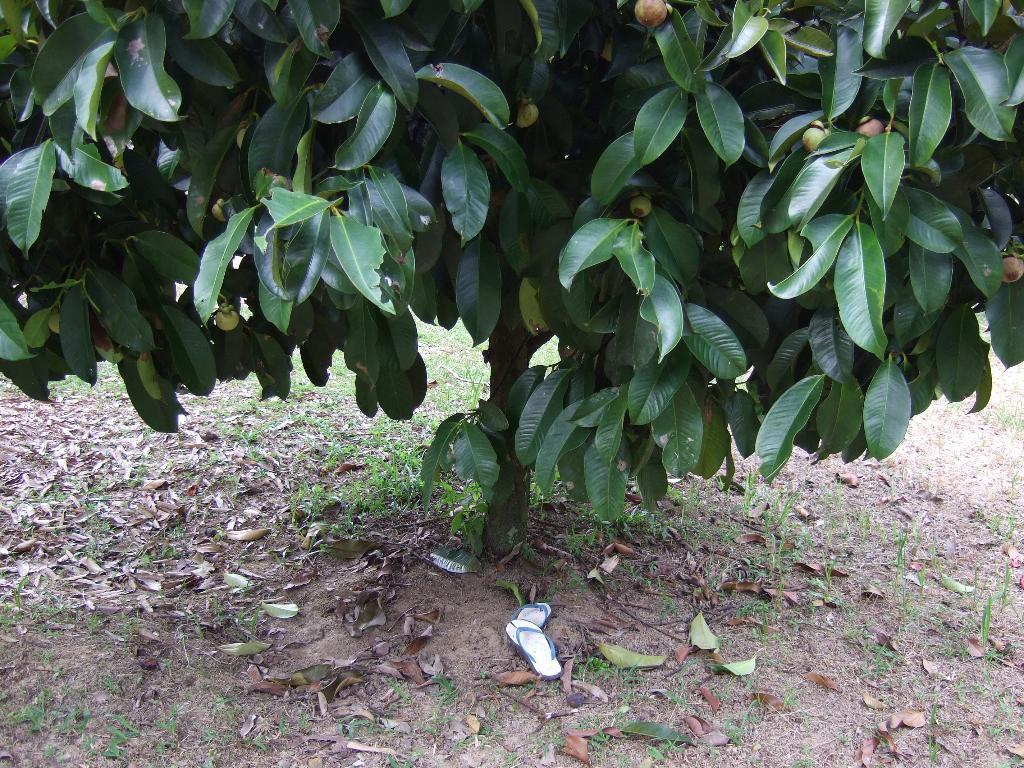Can you describe this image briefly? This is a tree with branches and leaves. I can see the fruits hanging to the tree. Here is a pair of sandals under the tree. These are the leaves lying on the ground. 